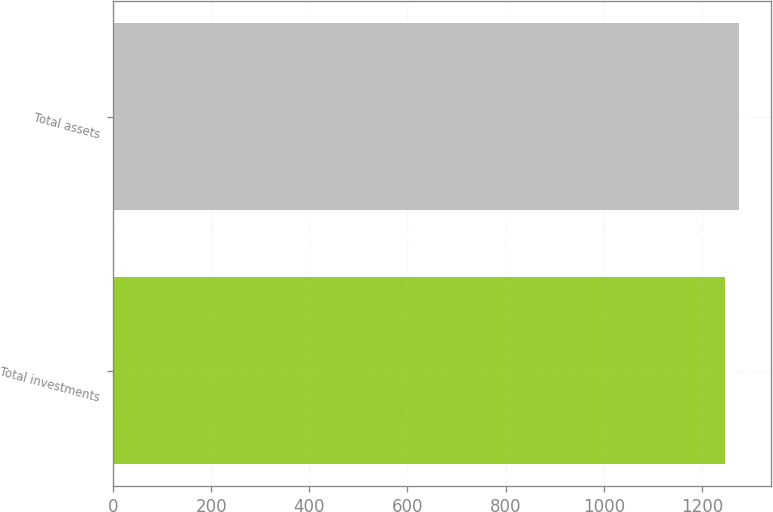Convert chart to OTSL. <chart><loc_0><loc_0><loc_500><loc_500><bar_chart><fcel>Total investments<fcel>Total assets<nl><fcel>1246<fcel>1276<nl></chart> 